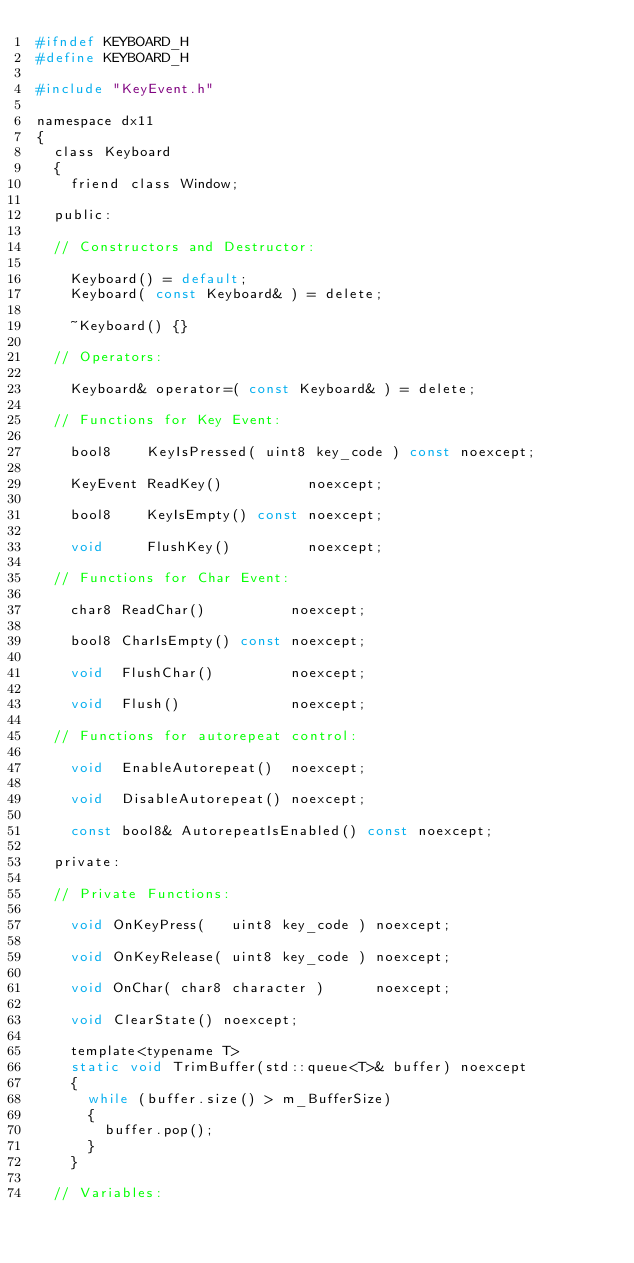Convert code to text. <code><loc_0><loc_0><loc_500><loc_500><_C_>#ifndef KEYBOARD_H
#define KEYBOARD_H

#include "KeyEvent.h"

namespace dx11
{
	class Keyboard
	{
		friend class Window;

	public:

	// Constructors and Destructor:

		Keyboard() = default;
		Keyboard( const Keyboard& ) = delete;

		~Keyboard() {}

	// Operators:

		Keyboard& operator=( const Keyboard& ) = delete;

	// Functions for Key Event:

		bool8    KeyIsPressed( uint8 key_code ) const noexcept;

		KeyEvent ReadKey()          noexcept;

		bool8    KeyIsEmpty() const noexcept;

		void     FlushKey()         noexcept;

	// Functions for Char Event:

		char8 ReadChar()          noexcept;

		bool8 CharIsEmpty() const noexcept;

		void  FlushChar()         noexcept;

		void  Flush()             noexcept;

	// Functions for autorepeat control:

		void  EnableAutorepeat()  noexcept;

		void  DisableAutorepeat() noexcept;

		const bool8& AutorepeatIsEnabled() const noexcept;

	private:

	// Private Functions:

		void OnKeyPress(   uint8 key_code ) noexcept;

		void OnKeyRelease( uint8 key_code ) noexcept;

		void OnChar( char8 character )      noexcept;

		void ClearState() noexcept;

		template<typename T>
		static void TrimBuffer(std::queue<T>& buffer) noexcept
		{
			while (buffer.size() > m_BufferSize)
			{
				buffer.pop();
			}
		}

	// Variables:
</code> 